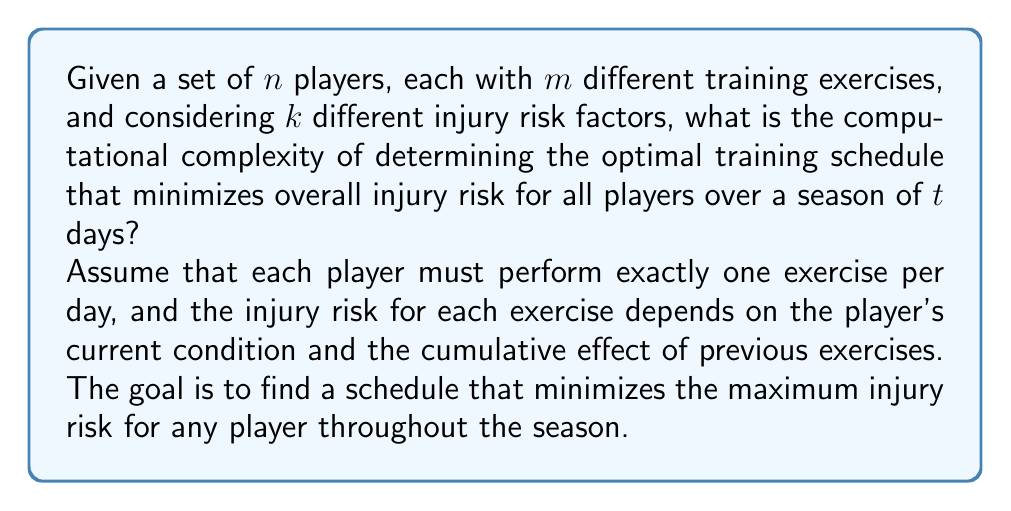Can you solve this math problem? To solve this problem, we need to consider the following steps:

1. For each player, we have $m$ choices of exercises for each of the $t$ days. This gives us $m^t$ possible schedules per player.

2. We need to consider all possible combinations of schedules for all $n$ players. This results in $(m^t)^n = m^{tn}$ total possible schedule combinations.

3. For each schedule combination, we need to calculate the injury risk for each player on each day, considering $k$ risk factors. This requires $O(nkt)$ operations per schedule.

4. To find the optimal schedule, we need to evaluate all possible schedule combinations and keep track of the one with the minimum maximum injury risk.

The total number of operations required is:

$$ O(m^{tn} \cdot nkt) $$

This is because we need to evaluate $m^{tn}$ schedule combinations, and for each combination, we perform $O(nkt)$ operations to calculate the injury risks.

In terms of computational complexity theory, this problem falls under the class of NP-hard problems. The decision version of this problem (asking if there exists a schedule with injury risk below a certain threshold) is NP-complete.

The exponential factor $m^{tn}$ in the time complexity indicates that this problem suffers from combinatorial explosion as the number of players, exercises, or days increases. This makes it infeasible to solve optimally for large instances using brute-force methods.

In practice, heuristic algorithms or approximation methods would be used to find near-optimal solutions in reasonable time frames. These might include genetic algorithms, simulated annealing, or other optimization techniques that can handle large search spaces efficiently.
Answer: The computational complexity of determining the optimal training schedule to minimize injury risk is $O(m^{tn} \cdot nkt)$, where $m$ is the number of exercises, $t$ is the number of days, $n$ is the number of players, and $k$ is the number of injury risk factors. This problem is NP-hard. 